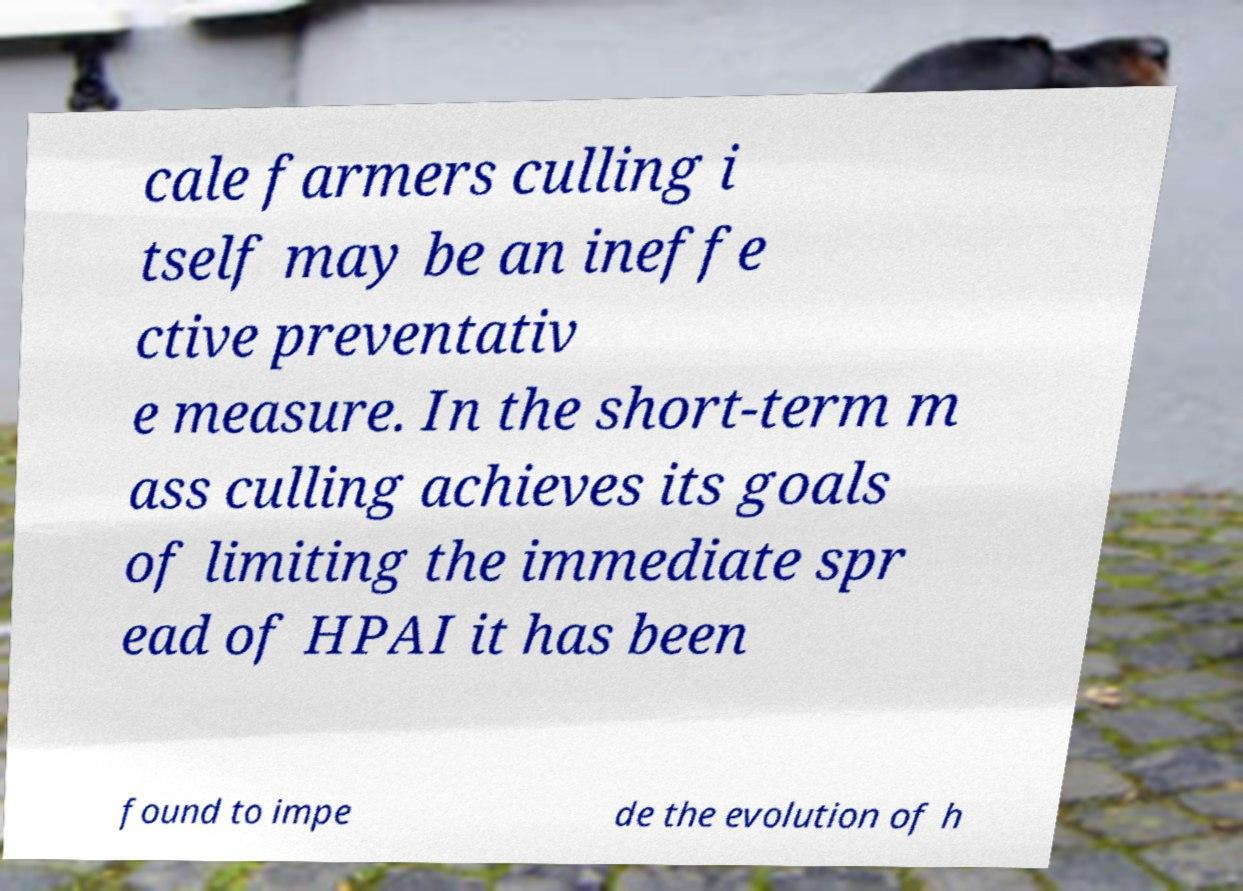I need the written content from this picture converted into text. Can you do that? cale farmers culling i tself may be an ineffe ctive preventativ e measure. In the short-term m ass culling achieves its goals of limiting the immediate spr ead of HPAI it has been found to impe de the evolution of h 